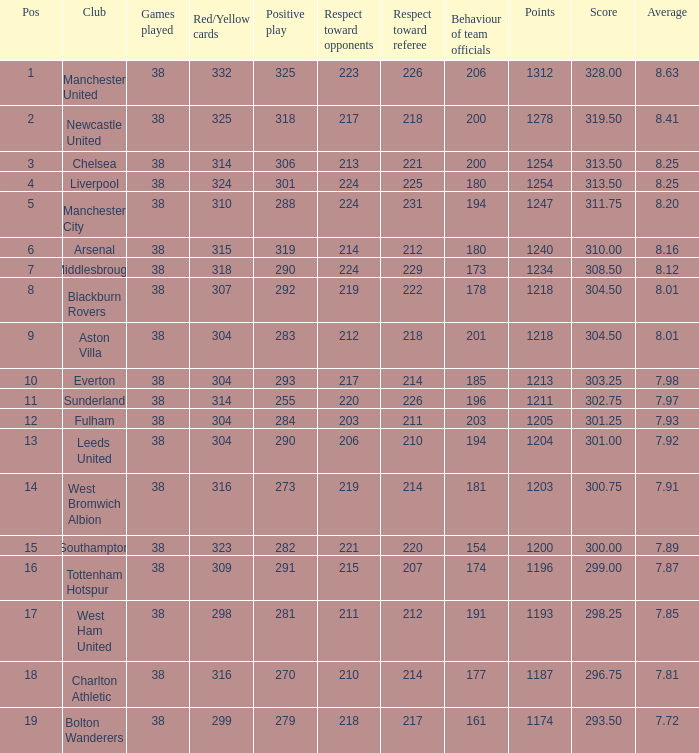Name the pos for west ham united 17.0. 